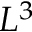<formula> <loc_0><loc_0><loc_500><loc_500>L ^ { 3 }</formula> 